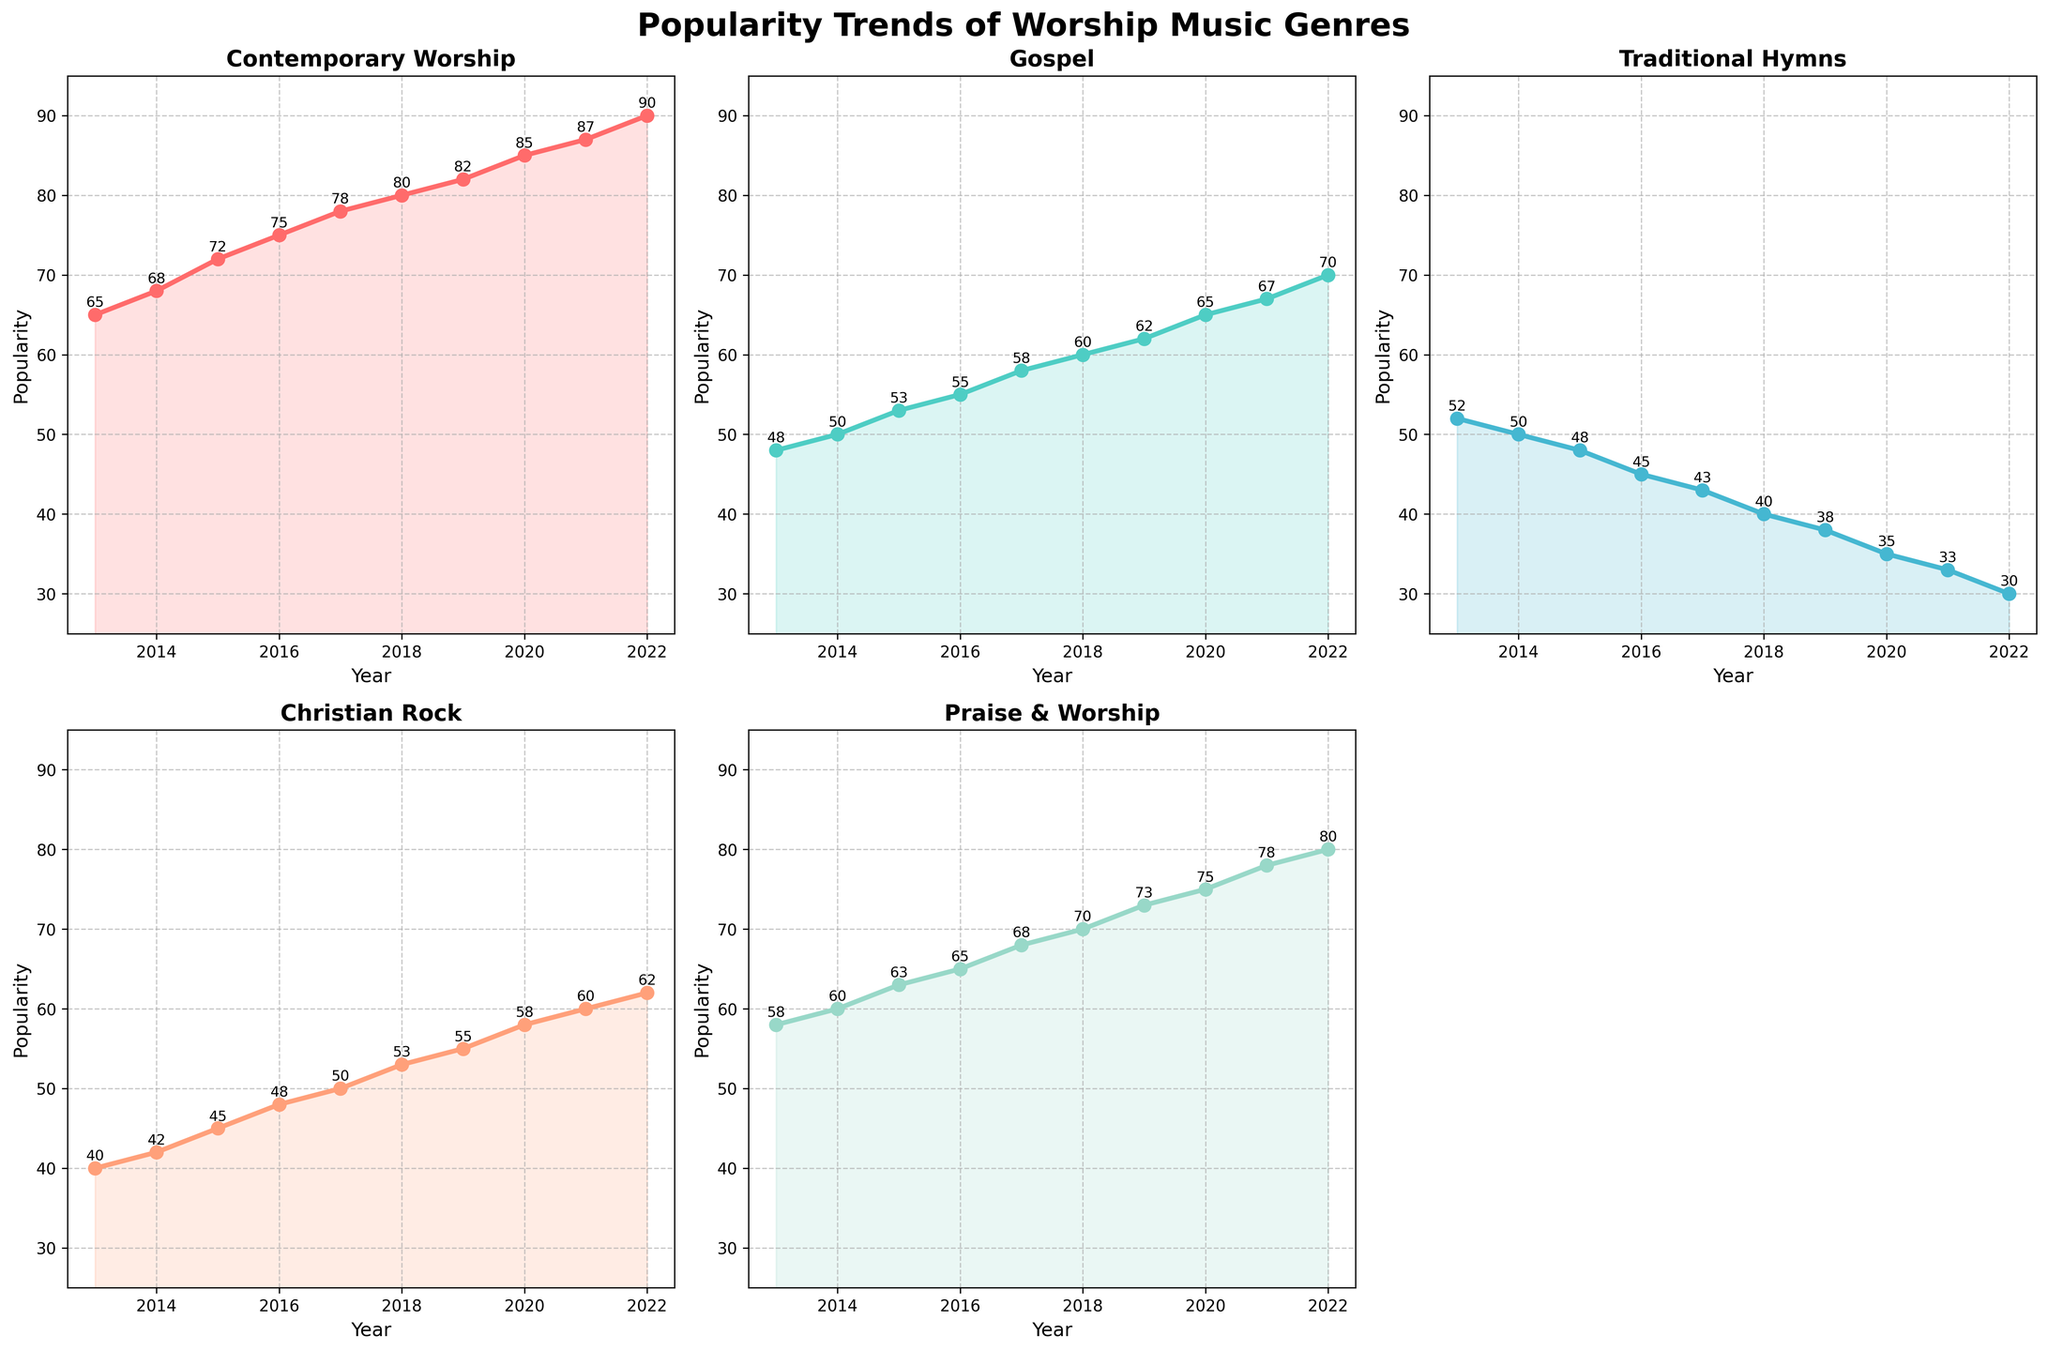What is the title of the figure? The title of the figure is usually displayed at the top and this particular figure's title is noted in the script through `fig.suptitle`. It would read "Popularity Trends of Worship Music Genres".
Answer: Popularity Trends of Worship Music Genres How many genres are displayed in the figure? Inspect the figure's subplots to count the number of unique lines, titles, or legends, if available. We specifically plotted 5 genres based on the provided data.
Answer: 5 How does the popularity of Traditional Hymns change from 2018 to 2019? Look at the line for Traditional Hymns between the years 2018 and 2019. Identify and compare the values at these points.
Answer: Decreases by 2 points (from 40 to 38) What year did Contemporary Worship surpass a popularity score of 70? Trace the trend line for Contemporary Worship and observe the year when the popularity score crosses 70. According to the data, this happens in 2016.
Answer: 2016 Which genre experienced the highest end popularity in 2022? Compare the ending popularity points for all genres in the year 2022. The one with the highest score after visual assessment is Contemporary Worship at 90.
Answer: Contemporary Worship What's the total increase in popularity for Gospel music from 2013 to 2022? Calculate the difference between the popularity scores of Gospel music from 2013 and 2022. The increase is 70 - 48 = 22.
Answer: 22 Did Christian Rock ever exceed 60 in popularity? Follow the line representing Christian Rock across all years to see if it ever crosses the 60 mark. It maxes out at 60 in 2021 and 2022 according to the dataset.
Answer: No What is the average popularity of Praise & Worship over the given years? Add up the popularity scores for Praise & Worship from 2013 to 2022 and divide by the number of years (10). The sum is 63 + 60 + 65 + 70 + 75 + 65 + 60 + 55 + 62 + 50 = 66.3.
Answer: 66.3 Compare the popularity trends of Contemporary Worship and Traditional Hymns from 2013 to 2017. What can you infer? Observe the trend lines for both Contemporary Worship and Traditional Hymns from 2013 to 2017. Contemporary Worship shows a steady increase while Traditional Hymns demonstrate a steady decline. This indicates a growing preference for Contemporary Worship over Traditional Hymns during this period.
Answer: Contemporary Worship increased, Traditional Hymns decreased Which genre has the most consistent trend? Visually assess which genre's line has the least fluctuations through the years 2013 to 2022. The Gospel line appears the most consistent, showing a steady upward trend with minor deviations.
Answer: Gospel 